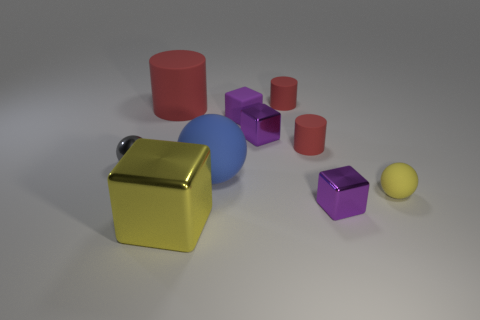How many red cylinders must be subtracted to get 1 red cylinders? 2 Subtract all tiny red cylinders. How many cylinders are left? 1 Subtract 1 cylinders. How many cylinders are left? 2 Subtract all blue balls. How many balls are left? 2 Subtract all brown balls. How many purple cubes are left? 3 Subtract all blocks. How many objects are left? 6 Subtract all small metallic things. Subtract all large blue matte spheres. How many objects are left? 6 Add 9 yellow metallic things. How many yellow metallic things are left? 10 Add 7 big purple rubber spheres. How many big purple rubber spheres exist? 7 Subtract 0 green cubes. How many objects are left? 10 